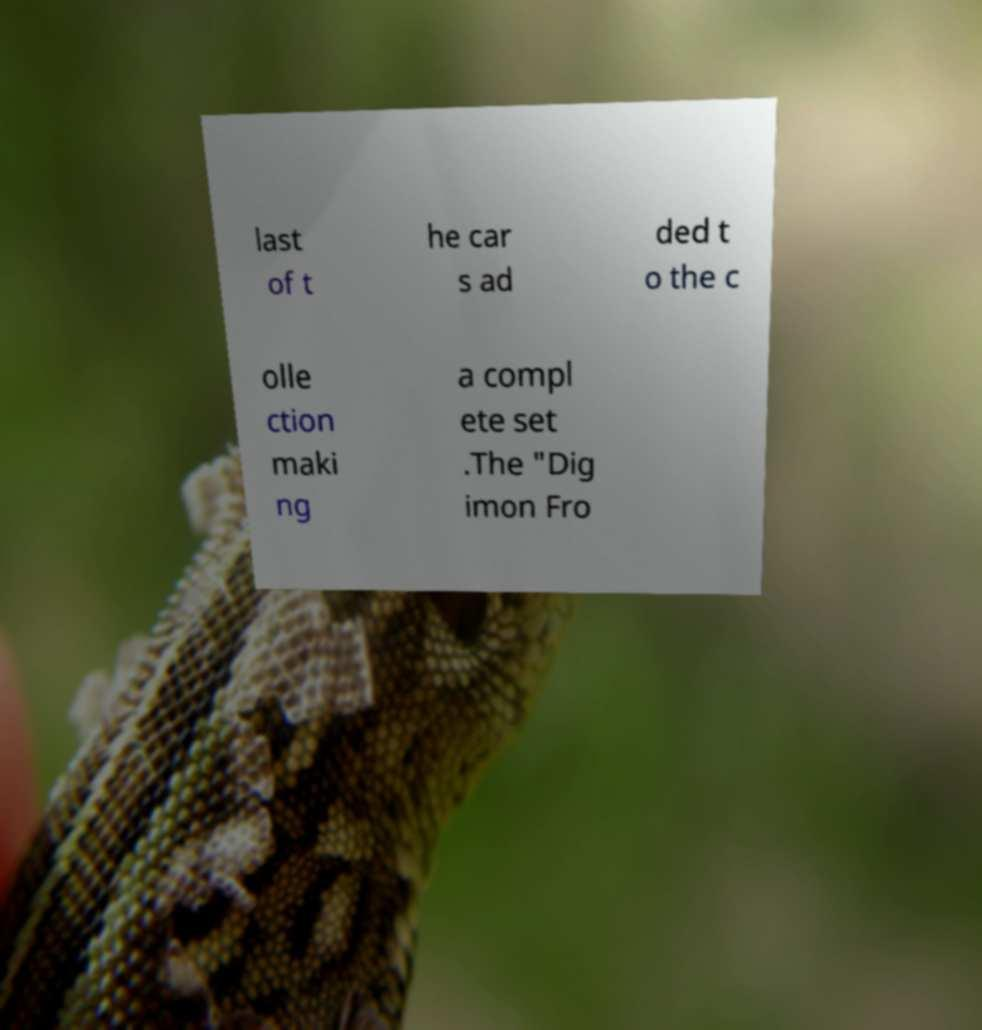There's text embedded in this image that I need extracted. Can you transcribe it verbatim? last of t he car s ad ded t o the c olle ction maki ng a compl ete set .The "Dig imon Fro 